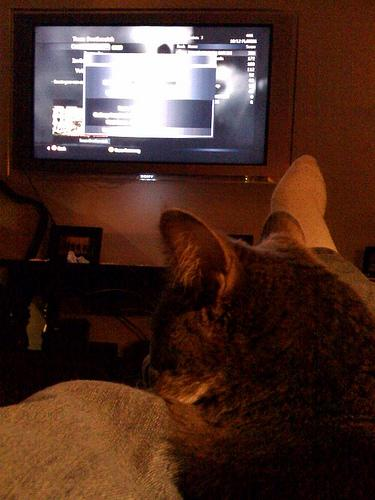What is the person doing in the bed? watching tv 